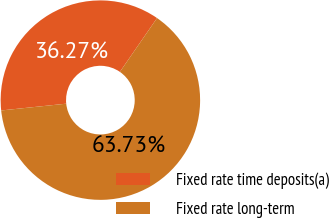<chart> <loc_0><loc_0><loc_500><loc_500><pie_chart><fcel>Fixed rate time deposits(a)<fcel>Fixed rate long-term<nl><fcel>36.27%<fcel>63.73%<nl></chart> 